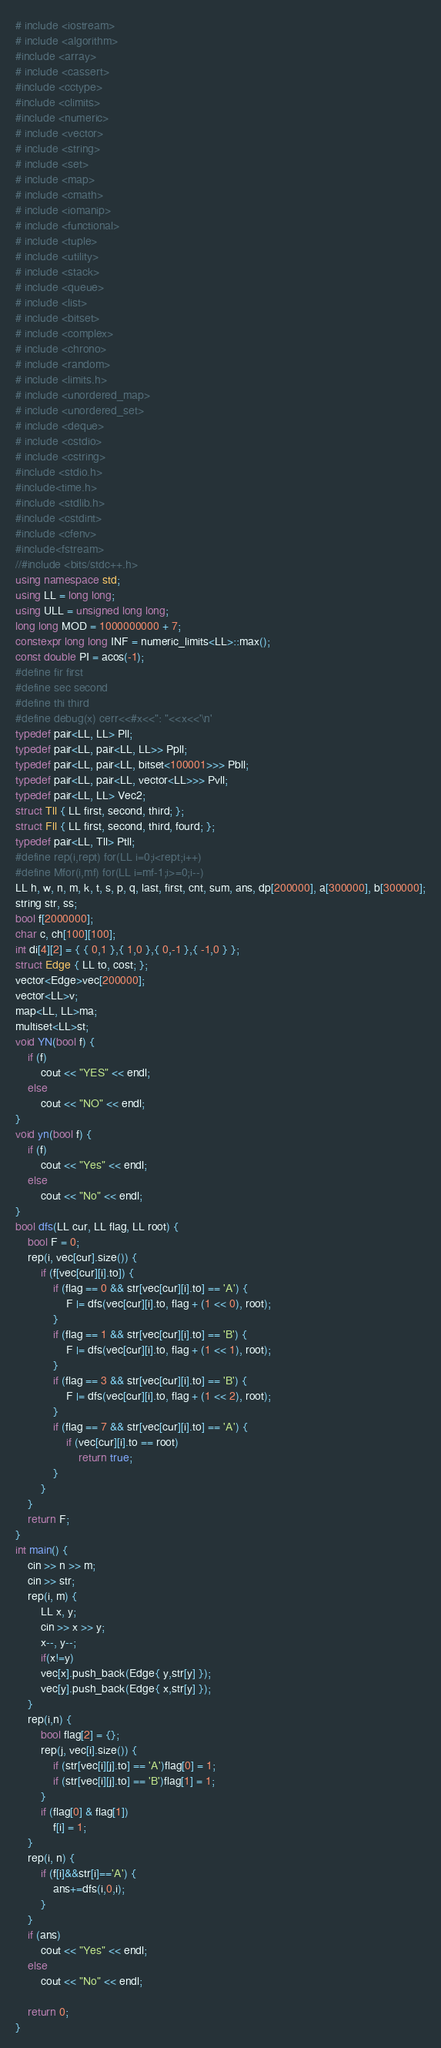Convert code to text. <code><loc_0><loc_0><loc_500><loc_500><_C++_># include <iostream>
# include <algorithm>
#include <array>
# include <cassert>
#include <cctype>
#include <climits>
#include <numeric>
# include <vector>
# include <string>
# include <set>
# include <map>
# include <cmath>
# include <iomanip>
# include <functional>
# include <tuple>
# include <utility>
# include <stack>
# include <queue>
# include <list>
# include <bitset>
# include <complex>
# include <chrono>
# include <random>
# include <limits.h>
# include <unordered_map>
# include <unordered_set>
# include <deque>
# include <cstdio>
# include <cstring>
#include <stdio.h>
#include<time.h>
#include <stdlib.h>
#include <cstdint>
#include <cfenv>
#include<fstream>
//#include <bits/stdc++.h>
using namespace std;
using LL = long long;
using ULL = unsigned long long;
long long MOD = 1000000000 + 7;
constexpr long long INF = numeric_limits<LL>::max();
const double PI = acos(-1);
#define fir first
#define sec second
#define thi third
#define debug(x) cerr<<#x<<": "<<x<<'\n'
typedef pair<LL, LL> Pll;
typedef pair<LL, pair<LL, LL>> Ppll;
typedef pair<LL, pair<LL, bitset<100001>>> Pbll;
typedef pair<LL, pair<LL, vector<LL>>> Pvll;
typedef pair<LL, LL> Vec2;
struct Tll { LL first, second, third; };
struct Fll { LL first, second, third, fourd; };
typedef pair<LL, Tll> Ptll;
#define rep(i,rept) for(LL i=0;i<rept;i++)
#define Mfor(i,mf) for(LL i=mf-1;i>=0;i--)
LL h, w, n, m, k, t, s, p, q, last, first, cnt, sum, ans, dp[200000], a[300000], b[300000];
string str, ss;
bool f[2000000];
char c, ch[100][100];
int di[4][2] = { { 0,1 },{ 1,0 },{ 0,-1 },{ -1,0 } };
struct Edge { LL to, cost; };
vector<Edge>vec[200000];
vector<LL>v;
map<LL, LL>ma;
multiset<LL>st;
void YN(bool f) {
	if (f)
		cout << "YES" << endl;
	else
		cout << "NO" << endl;
}
void yn(bool f) {
	if (f)
		cout << "Yes" << endl;
	else
		cout << "No" << endl;
}
bool dfs(LL cur, LL flag, LL root) {
	bool F = 0;
	rep(i, vec[cur].size()) {
		if (f[vec[cur][i].to]) {
			if (flag == 0 && str[vec[cur][i].to] == 'A') {
				F |= dfs(vec[cur][i].to, flag + (1 << 0), root);
			}
			if (flag == 1 && str[vec[cur][i].to] == 'B') {
				F |= dfs(vec[cur][i].to, flag + (1 << 1), root);
			}
			if (flag == 3 && str[vec[cur][i].to] == 'B') {
				F |= dfs(vec[cur][i].to, flag + (1 << 2), root);
			}
			if (flag == 7 && str[vec[cur][i].to] == 'A') {
				if (vec[cur][i].to == root)
					return true;
			}
		}
	}
	return F;
}
int main() {
	cin >> n >> m;
	cin >> str;
	rep(i, m) {
		LL x, y;
		cin >> x >> y;
		x--, y--;
		if(x!=y)
		vec[x].push_back(Edge{ y,str[y] });
		vec[y].push_back(Edge{ x,str[y] });
	}
	rep(i,n) {
		bool flag[2] = {};
		rep(j, vec[i].size()) {
			if (str[vec[i][j].to] == 'A')flag[0] = 1;
			if (str[vec[i][j].to] == 'B')flag[1] = 1;
		}
		if (flag[0] & flag[1])
			f[i] = 1;
	}
	rep(i, n) {
		if (f[i]&&str[i]=='A') {
			ans+=dfs(i,0,i);
		}
	}
	if (ans)
		cout << "Yes" << endl;
	else
		cout << "No" << endl;

	return 0;
}
</code> 